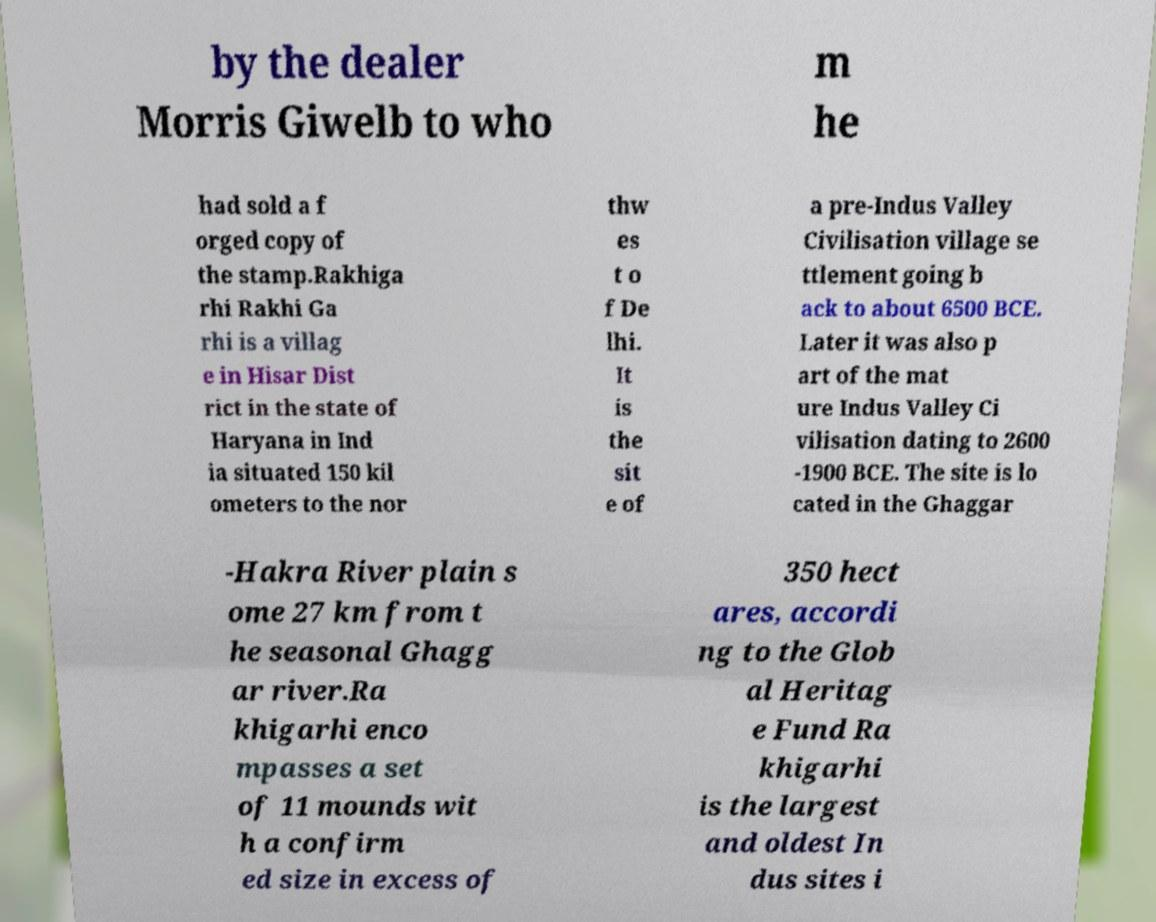Please identify and transcribe the text found in this image. by the dealer Morris Giwelb to who m he had sold a f orged copy of the stamp.Rakhiga rhi Rakhi Ga rhi is a villag e in Hisar Dist rict in the state of Haryana in Ind ia situated 150 kil ometers to the nor thw es t o f De lhi. It is the sit e of a pre-Indus Valley Civilisation village se ttlement going b ack to about 6500 BCE. Later it was also p art of the mat ure Indus Valley Ci vilisation dating to 2600 -1900 BCE. The site is lo cated in the Ghaggar -Hakra River plain s ome 27 km from t he seasonal Ghagg ar river.Ra khigarhi enco mpasses a set of 11 mounds wit h a confirm ed size in excess of 350 hect ares, accordi ng to the Glob al Heritag e Fund Ra khigarhi is the largest and oldest In dus sites i 